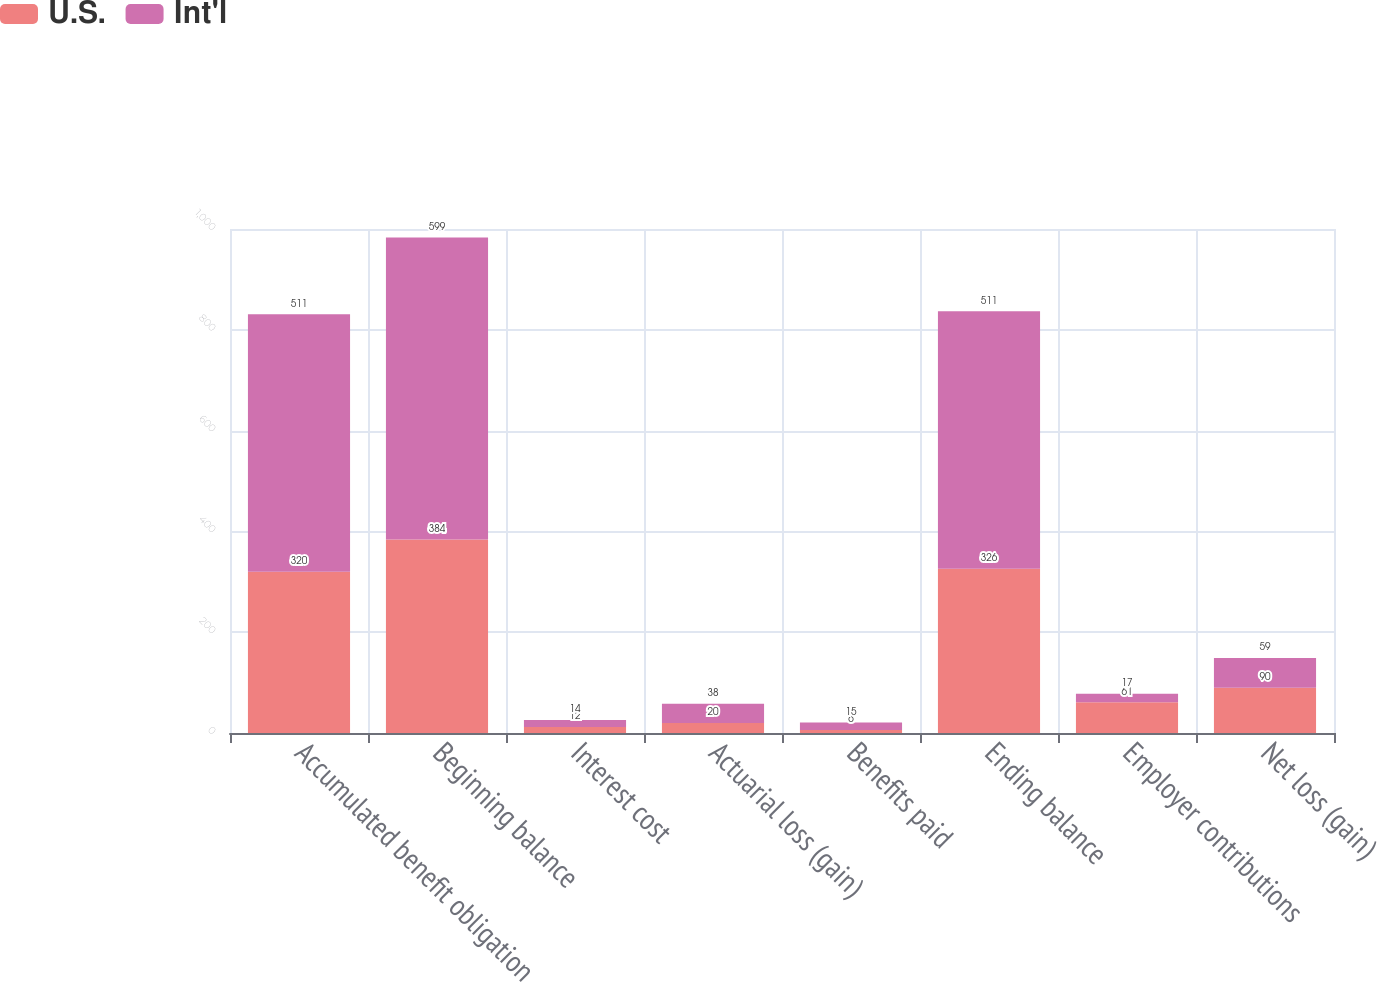Convert chart. <chart><loc_0><loc_0><loc_500><loc_500><stacked_bar_chart><ecel><fcel>Accumulated benefit obligation<fcel>Beginning balance<fcel>Interest cost<fcel>Actuarial loss (gain)<fcel>Benefits paid<fcel>Ending balance<fcel>Employer contributions<fcel>Net loss (gain)<nl><fcel>U.S.<fcel>320<fcel>384<fcel>12<fcel>20<fcel>6<fcel>326<fcel>61<fcel>90<nl><fcel>Int'l<fcel>511<fcel>599<fcel>14<fcel>38<fcel>15<fcel>511<fcel>17<fcel>59<nl></chart> 